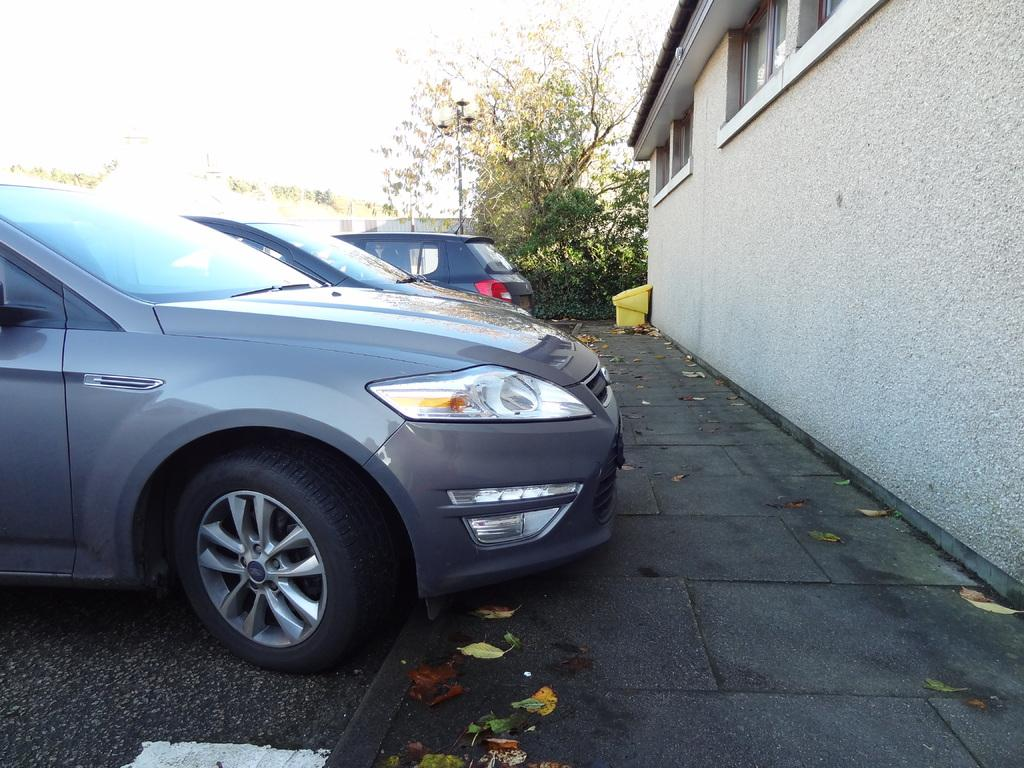How many cars are in the image? There are two cars in the image. What type of structure is present in the image? There is a building with windows in the image. What can be seen in the background of the image? Trees and the sky are visible in the background of the image. Is there a man holding a curtain in the image? There is no man holding a curtain in the image. What type of celebration is taking place in the image? There is no indication of a birthday or any other celebration in the image. 